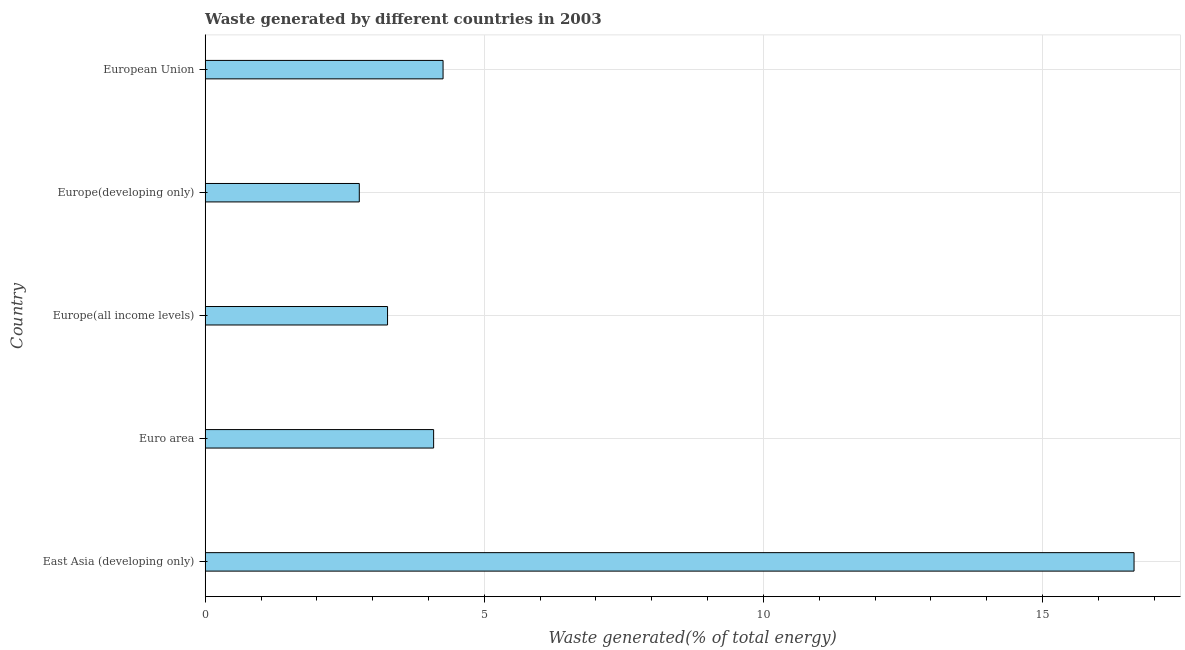What is the title of the graph?
Give a very brief answer. Waste generated by different countries in 2003. What is the label or title of the X-axis?
Make the answer very short. Waste generated(% of total energy). What is the amount of waste generated in East Asia (developing only)?
Provide a short and direct response. 16.64. Across all countries, what is the maximum amount of waste generated?
Provide a succinct answer. 16.64. Across all countries, what is the minimum amount of waste generated?
Your answer should be compact. 2.76. In which country was the amount of waste generated maximum?
Provide a succinct answer. East Asia (developing only). In which country was the amount of waste generated minimum?
Your answer should be very brief. Europe(developing only). What is the sum of the amount of waste generated?
Your answer should be very brief. 31.02. What is the difference between the amount of waste generated in Europe(all income levels) and European Union?
Ensure brevity in your answer.  -0.99. What is the average amount of waste generated per country?
Offer a very short reply. 6.2. What is the median amount of waste generated?
Ensure brevity in your answer.  4.09. What is the ratio of the amount of waste generated in Europe(developing only) to that in European Union?
Make the answer very short. 0.65. Is the difference between the amount of waste generated in East Asia (developing only) and Euro area greater than the difference between any two countries?
Provide a short and direct response. No. What is the difference between the highest and the second highest amount of waste generated?
Keep it short and to the point. 12.38. What is the difference between the highest and the lowest amount of waste generated?
Your answer should be very brief. 13.88. In how many countries, is the amount of waste generated greater than the average amount of waste generated taken over all countries?
Your response must be concise. 1. How many bars are there?
Your answer should be compact. 5. Are all the bars in the graph horizontal?
Ensure brevity in your answer.  Yes. What is the difference between two consecutive major ticks on the X-axis?
Your response must be concise. 5. What is the Waste generated(% of total energy) of East Asia (developing only)?
Your answer should be compact. 16.64. What is the Waste generated(% of total energy) of Euro area?
Your answer should be very brief. 4.09. What is the Waste generated(% of total energy) in Europe(all income levels)?
Ensure brevity in your answer.  3.27. What is the Waste generated(% of total energy) in Europe(developing only)?
Keep it short and to the point. 2.76. What is the Waste generated(% of total energy) of European Union?
Give a very brief answer. 4.26. What is the difference between the Waste generated(% of total energy) in East Asia (developing only) and Euro area?
Your answer should be compact. 12.55. What is the difference between the Waste generated(% of total energy) in East Asia (developing only) and Europe(all income levels)?
Provide a short and direct response. 13.37. What is the difference between the Waste generated(% of total energy) in East Asia (developing only) and Europe(developing only)?
Your answer should be compact. 13.88. What is the difference between the Waste generated(% of total energy) in East Asia (developing only) and European Union?
Your response must be concise. 12.38. What is the difference between the Waste generated(% of total energy) in Euro area and Europe(all income levels)?
Ensure brevity in your answer.  0.83. What is the difference between the Waste generated(% of total energy) in Euro area and Europe(developing only)?
Make the answer very short. 1.33. What is the difference between the Waste generated(% of total energy) in Euro area and European Union?
Give a very brief answer. -0.17. What is the difference between the Waste generated(% of total energy) in Europe(all income levels) and Europe(developing only)?
Offer a terse response. 0.51. What is the difference between the Waste generated(% of total energy) in Europe(all income levels) and European Union?
Your answer should be compact. -0.99. What is the difference between the Waste generated(% of total energy) in Europe(developing only) and European Union?
Your response must be concise. -1.5. What is the ratio of the Waste generated(% of total energy) in East Asia (developing only) to that in Euro area?
Make the answer very short. 4.07. What is the ratio of the Waste generated(% of total energy) in East Asia (developing only) to that in Europe(all income levels)?
Offer a very short reply. 5.09. What is the ratio of the Waste generated(% of total energy) in East Asia (developing only) to that in Europe(developing only)?
Give a very brief answer. 6.03. What is the ratio of the Waste generated(% of total energy) in East Asia (developing only) to that in European Union?
Offer a very short reply. 3.9. What is the ratio of the Waste generated(% of total energy) in Euro area to that in Europe(all income levels)?
Your answer should be very brief. 1.25. What is the ratio of the Waste generated(% of total energy) in Euro area to that in Europe(developing only)?
Give a very brief answer. 1.48. What is the ratio of the Waste generated(% of total energy) in Euro area to that in European Union?
Your answer should be very brief. 0.96. What is the ratio of the Waste generated(% of total energy) in Europe(all income levels) to that in Europe(developing only)?
Offer a very short reply. 1.18. What is the ratio of the Waste generated(% of total energy) in Europe(all income levels) to that in European Union?
Provide a succinct answer. 0.77. What is the ratio of the Waste generated(% of total energy) in Europe(developing only) to that in European Union?
Offer a terse response. 0.65. 